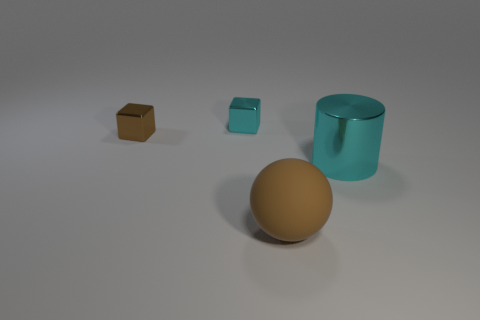Add 3 large objects. How many objects exist? 7 Subtract all cylinders. How many objects are left? 3 Add 2 large objects. How many large objects exist? 4 Subtract 0 purple balls. How many objects are left? 4 Subtract all large shiny cylinders. Subtract all large blocks. How many objects are left? 3 Add 2 tiny brown shiny things. How many tiny brown shiny things are left? 3 